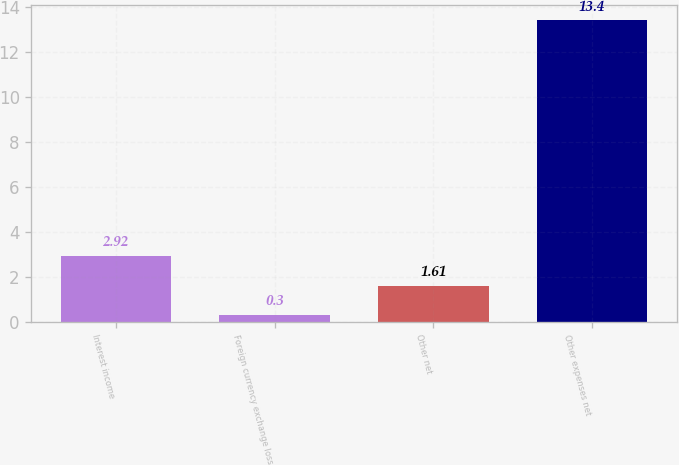Convert chart. <chart><loc_0><loc_0><loc_500><loc_500><bar_chart><fcel>Interest income<fcel>Foreign currency exchange loss<fcel>Other net<fcel>Other expenses net<nl><fcel>2.92<fcel>0.3<fcel>1.61<fcel>13.4<nl></chart> 